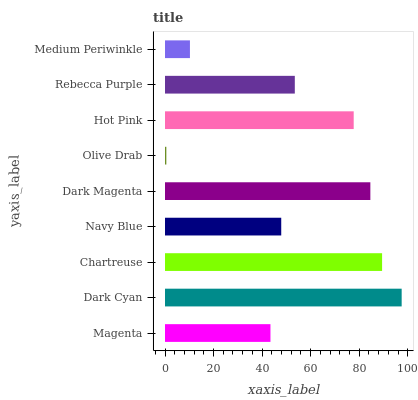Is Olive Drab the minimum?
Answer yes or no. Yes. Is Dark Cyan the maximum?
Answer yes or no. Yes. Is Chartreuse the minimum?
Answer yes or no. No. Is Chartreuse the maximum?
Answer yes or no. No. Is Dark Cyan greater than Chartreuse?
Answer yes or no. Yes. Is Chartreuse less than Dark Cyan?
Answer yes or no. Yes. Is Chartreuse greater than Dark Cyan?
Answer yes or no. No. Is Dark Cyan less than Chartreuse?
Answer yes or no. No. Is Rebecca Purple the high median?
Answer yes or no. Yes. Is Rebecca Purple the low median?
Answer yes or no. Yes. Is Dark Magenta the high median?
Answer yes or no. No. Is Chartreuse the low median?
Answer yes or no. No. 